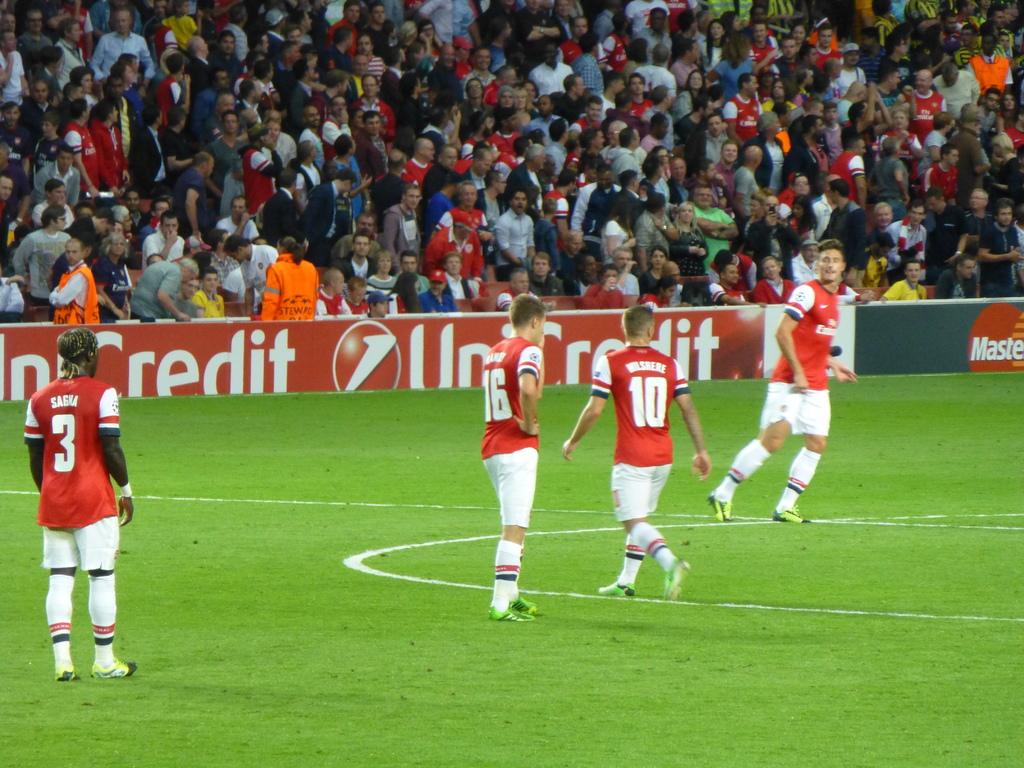What is the number of the player to the very right?
Offer a terse response. 10. What number is the player on the left?
Give a very brief answer. 3. 